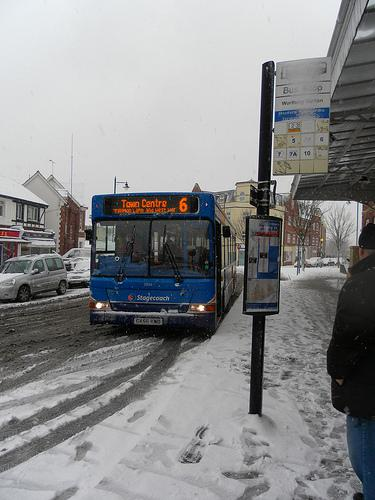Question: what is the weather in the picture?
Choices:
A. Rainy.
B. Sunny.
C. Overcast.
D. Snow.
Answer with the letter. Answer: D Question: how do you think this man is getting to Town Centre?
Choices:
A. Car.
B. Bus.
C. Train.
D. By Foot.
Answer with the letter. Answer: B Question: where is the man standing?
Choices:
A. A rest area.
B. Bus stop.
C. A sidewalk.
D. An alleyway.
Answer with the letter. Answer: B Question: when does the next bus arrive?
Choices:
A. This afternoon.
B. Now.
C. This evening.
D. Tomorrow morning.
Answer with the letter. Answer: B 